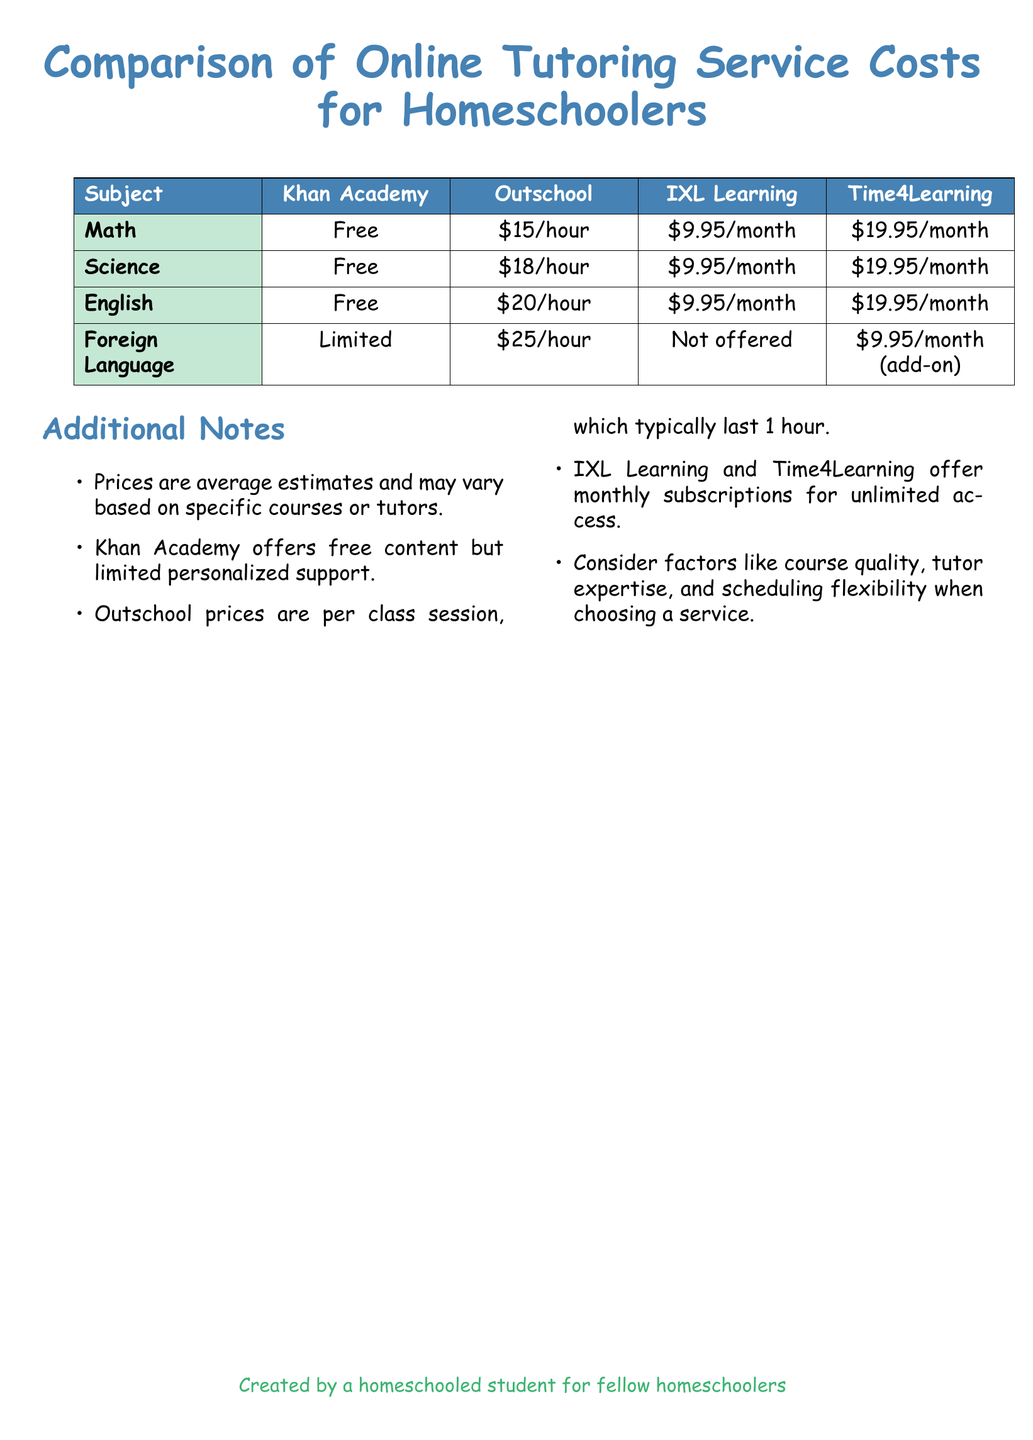What is the average cost for Math tutoring on Outschool? The average cost for Math tutoring on Outschool is stated in the table as $15/hour.
Answer: $15/hour Which tutoring service offers free content for English? The document mentions that Khan Academy offers free content for English.
Answer: Khan Academy How much does Time4Learning charge per month for Science? The document specifies that Time4Learning charges $19.95/month for Science.
Answer: $19.95/month What is the cost of Foreign Language tutoring on Outschool? The table lists the cost for Foreign Language tutoring on Outschool as $25/hour.
Answer: $25/hour Which services provide monthly subscriptions? The document states that IXL Learning and Time4Learning offer monthly subscriptions.
Answer: IXL Learning and Time4Learning What is the limitation of Khan Academy's Foreign Language offerings? The document indicates that Khan Academy has a "Limited" offering for Foreign Language.
Answer: Limited How do Outschool prices relate to session duration? The additional notes clarify that Outschool prices are per class session, which typically last 1 hour.
Answer: Per class session, lasting 1 hour Which subject does not have a tutoring service listed under IXL Learning? The document states that Foreign Language is not offered by IXL Learning.
Answer: Foreign Language What factor should be considered when choosing a tutoring service? The document advises considering factors like course quality, tutor expertise, and scheduling flexibility.
Answer: Course quality, tutor expertise, scheduling flexibility 